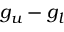<formula> <loc_0><loc_0><loc_500><loc_500>g _ { u } - g _ { l }</formula> 